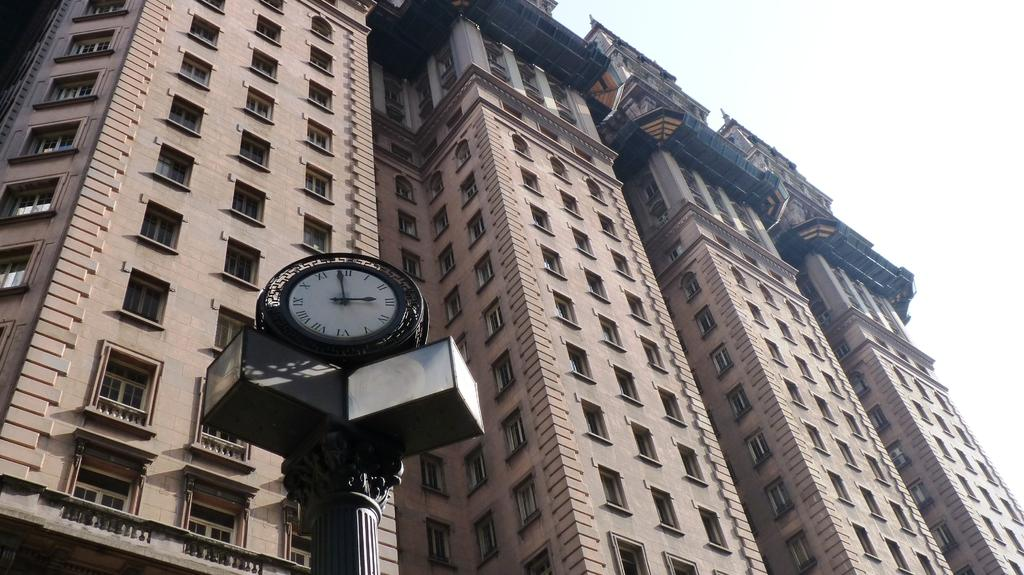Provide a one-sentence caption for the provided image. A clock has the numeral XII at the top and VI at the bottom. 